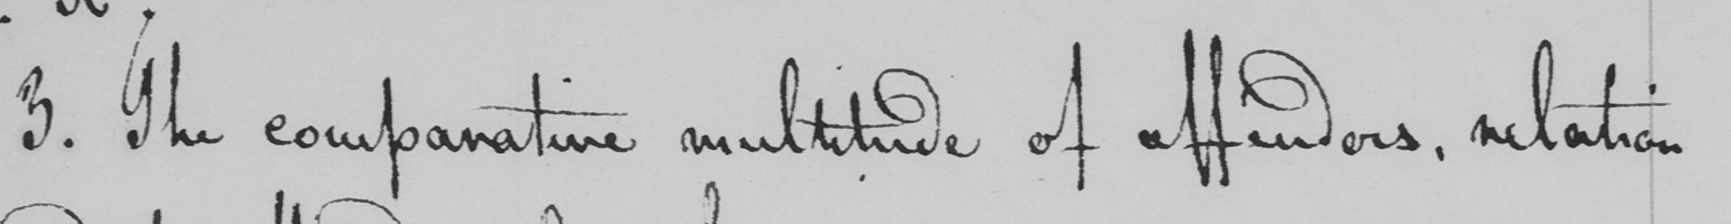Can you read and transcribe this handwriting? 3 . The comparative multitude of affenders , relation 